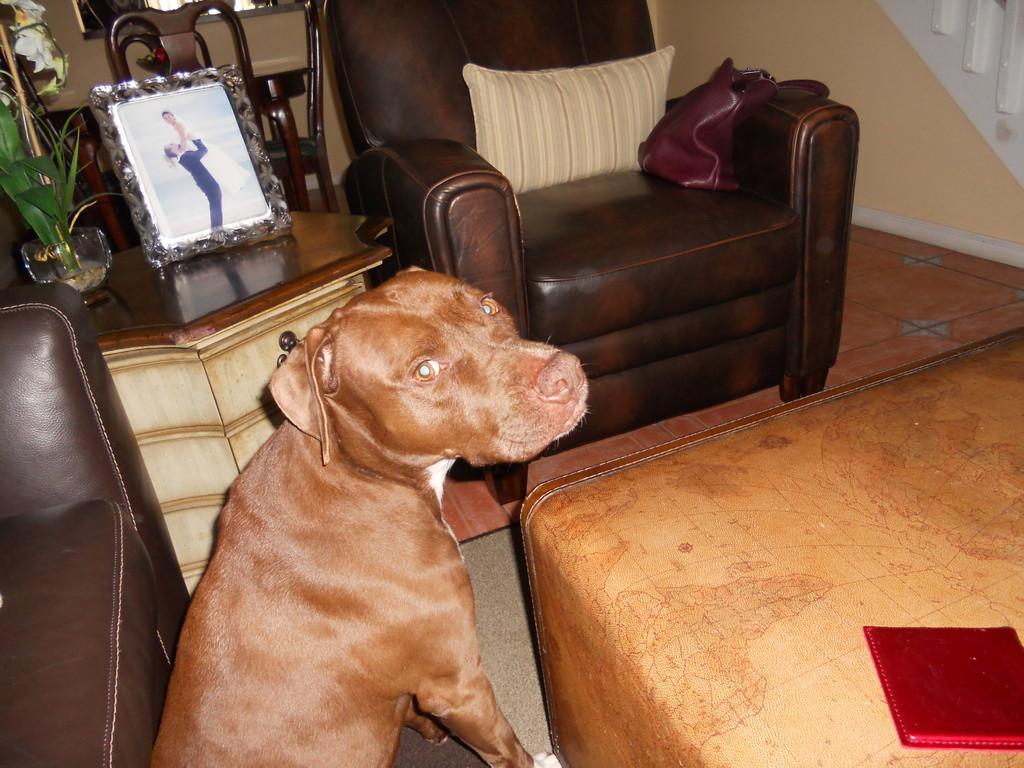Could you give a brief overview of what you see in this image? In this picture there is dog standing in front of brown sofa. In the background there is a photo frame. 